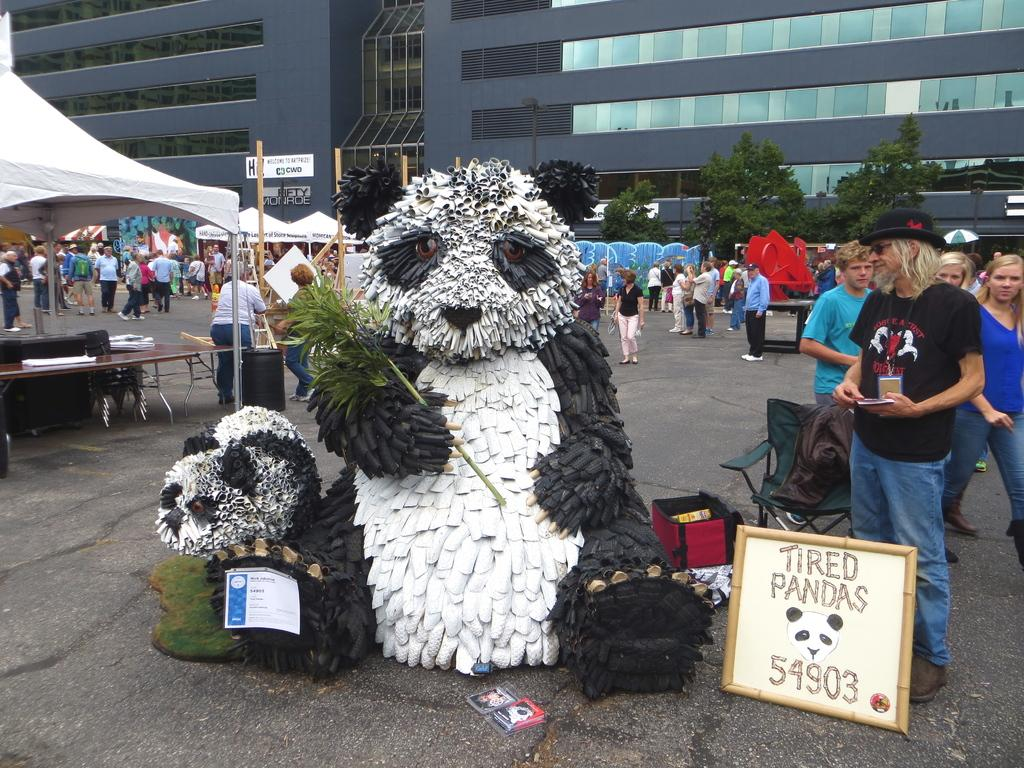What is the main structure in the image? There is a big building in the image. Are there any people present in the image? Yes, there are people standing in the image. What else can be seen in the image besides the building and people? There are stakes arranged in the image. Is there any object in the image that might be considered a toy? Yes, there is a teddy in the image. Reasoning: Let' Let's think step by step in order to produce the conversation. We start by identifying the main structure in the image, which is the big building. Then, we mention the presence of people in the image, as well as the stakes arranged in the image. Finally, we acknowledge the presence of a toy, the teddy, to provide a more complete description of the image. Absurd Question/Answer: What direction are the people in the image facing? The provided facts do not specify the direction the people are facing. How does the teddy in the image join the people? The teddy is an inanimate object and cannot join the people in the image. 